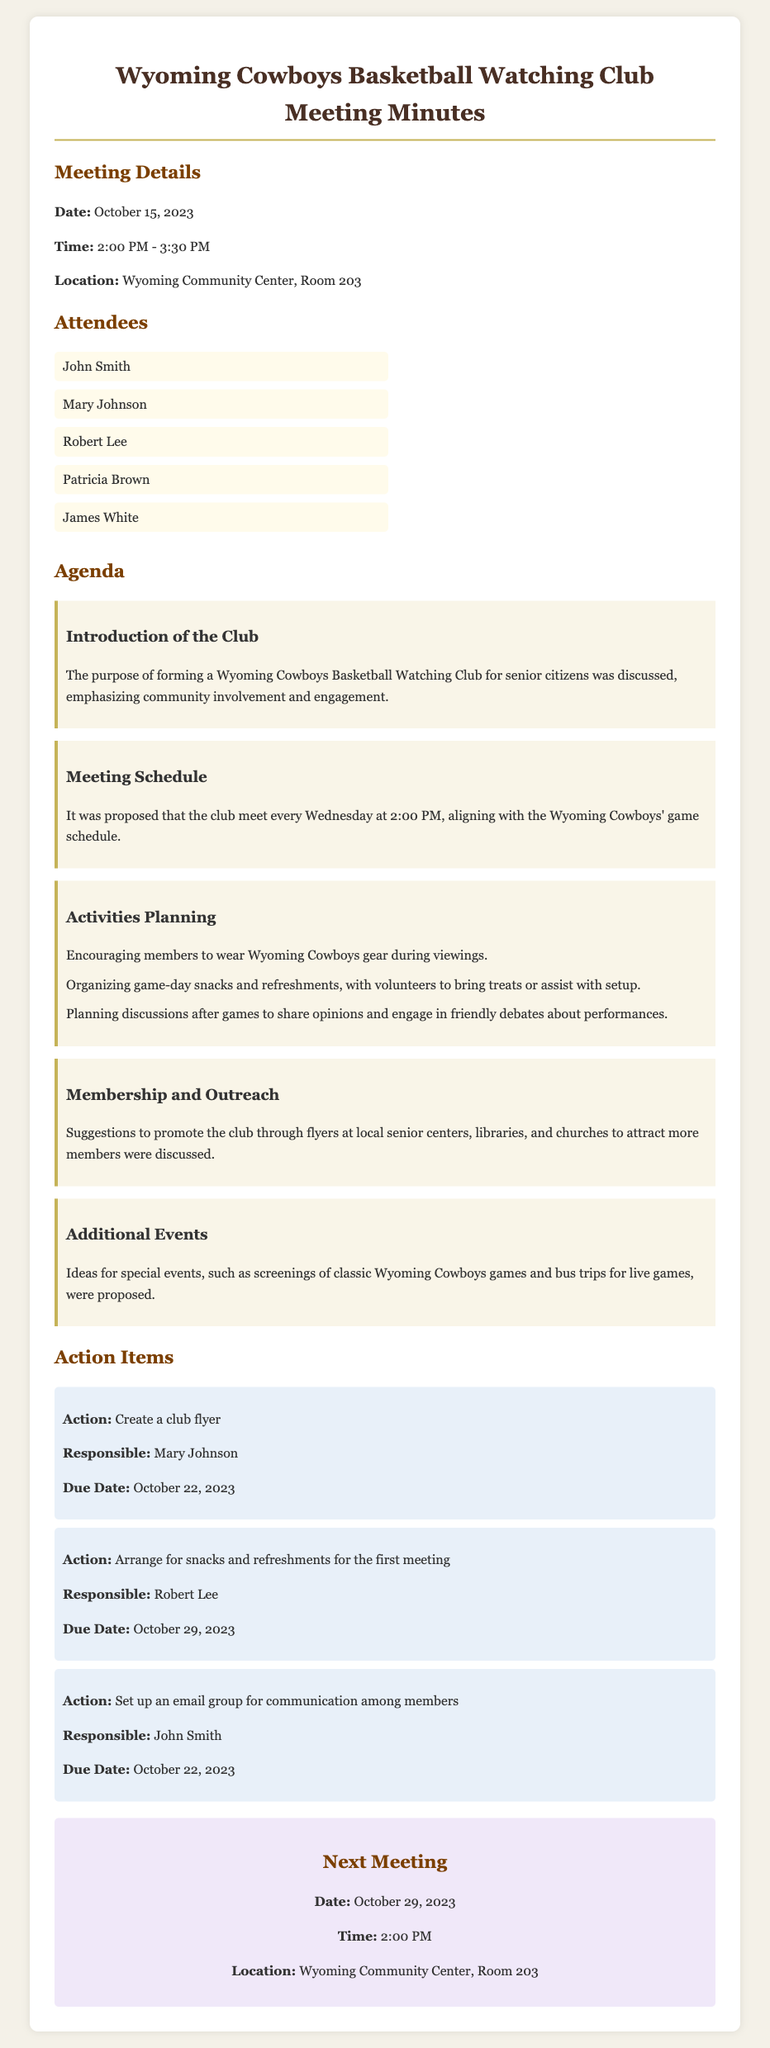What was the date of the meeting? The date of the meeting is explicitly stated in the document.
Answer: October 15, 2023 What time did the meeting start? The start time of the meeting is mentioned in the details section.
Answer: 2:00 PM Who is responsible for creating the club flyer? This information is found in the action item section regarding the flyer.
Answer: Mary Johnson What activities will the club members engage in during viewings? This information can be retrieved from the activities planning section.
Answer: Game-day snacks and refreshments When is the next meeting scheduled? The next meeting date is specifically mentioned as part of the conclusion.
Answer: October 29, 2023 How often will the club meet? The frequency of meetings is discussed in the meeting schedule agenda item.
Answer: Every Wednesday What was the purpose of forming the club? The purpose is outlined in the introduction of the club section.
Answer: Community involvement and engagement How will the club promote membership? The strategies for promoting membership are listed in the membership and outreach section.
Answer: Flyers at local senior centers, libraries, and churches What is the location of the next meeting? The location of the next meeting is stated in the next meeting section.
Answer: Wyoming Community Center, Room 203 